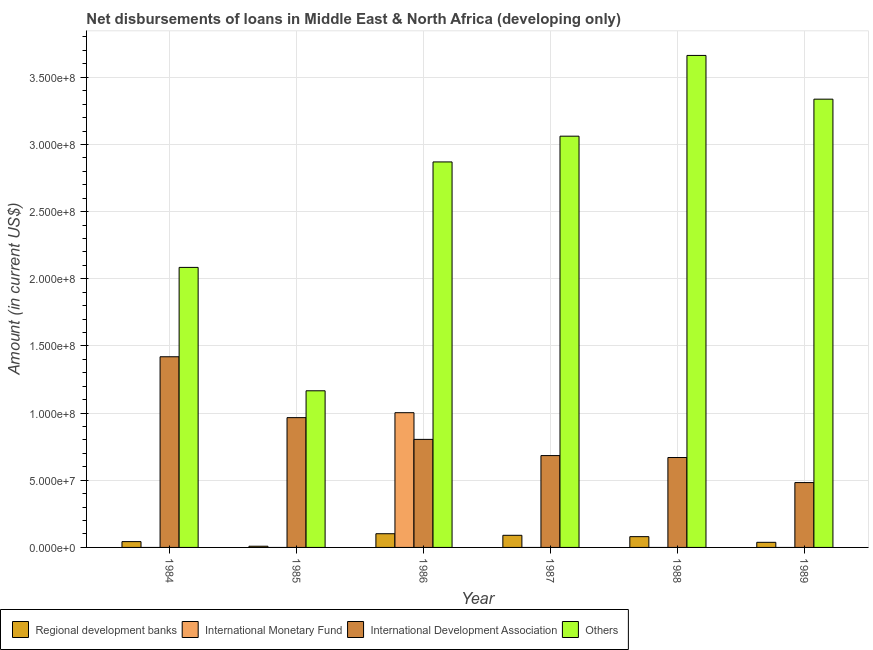How many different coloured bars are there?
Make the answer very short. 4. How many bars are there on the 3rd tick from the left?
Your response must be concise. 4. How many bars are there on the 5th tick from the right?
Provide a succinct answer. 3. What is the amount of loan disimbursed by other organisations in 1989?
Provide a succinct answer. 3.34e+08. Across all years, what is the maximum amount of loan disimbursed by international monetary fund?
Provide a short and direct response. 1.00e+08. Across all years, what is the minimum amount of loan disimbursed by other organisations?
Your answer should be very brief. 1.17e+08. In which year was the amount of loan disimbursed by international monetary fund maximum?
Offer a very short reply. 1986. What is the total amount of loan disimbursed by regional development banks in the graph?
Give a very brief answer. 3.63e+07. What is the difference between the amount of loan disimbursed by regional development banks in 1984 and that in 1987?
Offer a terse response. -4.69e+06. What is the difference between the amount of loan disimbursed by international development association in 1989 and the amount of loan disimbursed by international monetary fund in 1984?
Provide a short and direct response. -9.37e+07. What is the average amount of loan disimbursed by international monetary fund per year?
Provide a succinct answer. 1.67e+07. In the year 1987, what is the difference between the amount of loan disimbursed by other organisations and amount of loan disimbursed by international development association?
Offer a very short reply. 0. In how many years, is the amount of loan disimbursed by other organisations greater than 270000000 US$?
Your answer should be very brief. 4. What is the ratio of the amount of loan disimbursed by other organisations in 1985 to that in 1988?
Offer a terse response. 0.32. Is the difference between the amount of loan disimbursed by other organisations in 1987 and 1989 greater than the difference between the amount of loan disimbursed by international monetary fund in 1987 and 1989?
Ensure brevity in your answer.  No. What is the difference between the highest and the second highest amount of loan disimbursed by international development association?
Offer a terse response. 4.53e+07. What is the difference between the highest and the lowest amount of loan disimbursed by international monetary fund?
Provide a short and direct response. 1.00e+08. In how many years, is the amount of loan disimbursed by international development association greater than the average amount of loan disimbursed by international development association taken over all years?
Ensure brevity in your answer.  2. Is the sum of the amount of loan disimbursed by regional development banks in 1985 and 1988 greater than the maximum amount of loan disimbursed by international monetary fund across all years?
Your answer should be very brief. No. Is it the case that in every year, the sum of the amount of loan disimbursed by international development association and amount of loan disimbursed by regional development banks is greater than the sum of amount of loan disimbursed by international monetary fund and amount of loan disimbursed by other organisations?
Offer a very short reply. No. Is it the case that in every year, the sum of the amount of loan disimbursed by regional development banks and amount of loan disimbursed by international monetary fund is greater than the amount of loan disimbursed by international development association?
Provide a short and direct response. No. How many bars are there?
Your answer should be compact. 19. What is the title of the graph?
Provide a succinct answer. Net disbursements of loans in Middle East & North Africa (developing only). Does "Minerals" appear as one of the legend labels in the graph?
Offer a very short reply. No. What is the Amount (in current US$) of Regional development banks in 1984?
Provide a succinct answer. 4.33e+06. What is the Amount (in current US$) in International Development Association in 1984?
Your response must be concise. 1.42e+08. What is the Amount (in current US$) of Others in 1984?
Make the answer very short. 2.08e+08. What is the Amount (in current US$) in Regional development banks in 1985?
Your response must be concise. 8.91e+05. What is the Amount (in current US$) of International Monetary Fund in 1985?
Your answer should be compact. 0. What is the Amount (in current US$) in International Development Association in 1985?
Provide a succinct answer. 9.66e+07. What is the Amount (in current US$) in Others in 1985?
Keep it short and to the point. 1.17e+08. What is the Amount (in current US$) in Regional development banks in 1986?
Make the answer very short. 1.02e+07. What is the Amount (in current US$) of International Monetary Fund in 1986?
Make the answer very short. 1.00e+08. What is the Amount (in current US$) of International Development Association in 1986?
Offer a very short reply. 8.04e+07. What is the Amount (in current US$) in Others in 1986?
Keep it short and to the point. 2.87e+08. What is the Amount (in current US$) in Regional development banks in 1987?
Make the answer very short. 9.02e+06. What is the Amount (in current US$) of International Monetary Fund in 1987?
Keep it short and to the point. 0. What is the Amount (in current US$) of International Development Association in 1987?
Your answer should be very brief. 6.84e+07. What is the Amount (in current US$) of Others in 1987?
Ensure brevity in your answer.  3.06e+08. What is the Amount (in current US$) of Regional development banks in 1988?
Give a very brief answer. 8.03e+06. What is the Amount (in current US$) of International Development Association in 1988?
Provide a short and direct response. 6.69e+07. What is the Amount (in current US$) of Others in 1988?
Provide a succinct answer. 3.66e+08. What is the Amount (in current US$) of Regional development banks in 1989?
Keep it short and to the point. 3.80e+06. What is the Amount (in current US$) of International Development Association in 1989?
Your answer should be compact. 4.83e+07. What is the Amount (in current US$) in Others in 1989?
Make the answer very short. 3.34e+08. Across all years, what is the maximum Amount (in current US$) of Regional development banks?
Make the answer very short. 1.02e+07. Across all years, what is the maximum Amount (in current US$) in International Monetary Fund?
Provide a short and direct response. 1.00e+08. Across all years, what is the maximum Amount (in current US$) of International Development Association?
Give a very brief answer. 1.42e+08. Across all years, what is the maximum Amount (in current US$) in Others?
Make the answer very short. 3.66e+08. Across all years, what is the minimum Amount (in current US$) of Regional development banks?
Offer a very short reply. 8.91e+05. Across all years, what is the minimum Amount (in current US$) in International Development Association?
Your answer should be very brief. 4.83e+07. Across all years, what is the minimum Amount (in current US$) in Others?
Keep it short and to the point. 1.17e+08. What is the total Amount (in current US$) in Regional development banks in the graph?
Your answer should be very brief. 3.63e+07. What is the total Amount (in current US$) in International Monetary Fund in the graph?
Your response must be concise. 1.00e+08. What is the total Amount (in current US$) in International Development Association in the graph?
Give a very brief answer. 5.03e+08. What is the total Amount (in current US$) of Others in the graph?
Give a very brief answer. 1.62e+09. What is the difference between the Amount (in current US$) of Regional development banks in 1984 and that in 1985?
Keep it short and to the point. 3.44e+06. What is the difference between the Amount (in current US$) in International Development Association in 1984 and that in 1985?
Keep it short and to the point. 4.53e+07. What is the difference between the Amount (in current US$) of Others in 1984 and that in 1985?
Offer a very short reply. 9.19e+07. What is the difference between the Amount (in current US$) in Regional development banks in 1984 and that in 1986?
Ensure brevity in your answer.  -5.86e+06. What is the difference between the Amount (in current US$) of International Development Association in 1984 and that in 1986?
Give a very brief answer. 6.15e+07. What is the difference between the Amount (in current US$) in Others in 1984 and that in 1986?
Provide a short and direct response. -7.85e+07. What is the difference between the Amount (in current US$) of Regional development banks in 1984 and that in 1987?
Give a very brief answer. -4.69e+06. What is the difference between the Amount (in current US$) in International Development Association in 1984 and that in 1987?
Ensure brevity in your answer.  7.36e+07. What is the difference between the Amount (in current US$) in Others in 1984 and that in 1987?
Ensure brevity in your answer.  -9.77e+07. What is the difference between the Amount (in current US$) in Regional development banks in 1984 and that in 1988?
Your answer should be very brief. -3.70e+06. What is the difference between the Amount (in current US$) in International Development Association in 1984 and that in 1988?
Ensure brevity in your answer.  7.50e+07. What is the difference between the Amount (in current US$) in Others in 1984 and that in 1988?
Your answer should be compact. -1.58e+08. What is the difference between the Amount (in current US$) in Regional development banks in 1984 and that in 1989?
Make the answer very short. 5.32e+05. What is the difference between the Amount (in current US$) of International Development Association in 1984 and that in 1989?
Offer a very short reply. 9.37e+07. What is the difference between the Amount (in current US$) in Others in 1984 and that in 1989?
Keep it short and to the point. -1.25e+08. What is the difference between the Amount (in current US$) in Regional development banks in 1985 and that in 1986?
Offer a very short reply. -9.30e+06. What is the difference between the Amount (in current US$) of International Development Association in 1985 and that in 1986?
Your response must be concise. 1.62e+07. What is the difference between the Amount (in current US$) of Others in 1985 and that in 1986?
Keep it short and to the point. -1.70e+08. What is the difference between the Amount (in current US$) in Regional development banks in 1985 and that in 1987?
Your response must be concise. -8.13e+06. What is the difference between the Amount (in current US$) of International Development Association in 1985 and that in 1987?
Offer a very short reply. 2.83e+07. What is the difference between the Amount (in current US$) in Others in 1985 and that in 1987?
Your response must be concise. -1.90e+08. What is the difference between the Amount (in current US$) in Regional development banks in 1985 and that in 1988?
Keep it short and to the point. -7.14e+06. What is the difference between the Amount (in current US$) of International Development Association in 1985 and that in 1988?
Offer a very short reply. 2.97e+07. What is the difference between the Amount (in current US$) in Others in 1985 and that in 1988?
Your response must be concise. -2.50e+08. What is the difference between the Amount (in current US$) of Regional development banks in 1985 and that in 1989?
Your answer should be compact. -2.91e+06. What is the difference between the Amount (in current US$) in International Development Association in 1985 and that in 1989?
Give a very brief answer. 4.84e+07. What is the difference between the Amount (in current US$) of Others in 1985 and that in 1989?
Your answer should be compact. -2.17e+08. What is the difference between the Amount (in current US$) in Regional development banks in 1986 and that in 1987?
Make the answer very short. 1.17e+06. What is the difference between the Amount (in current US$) of International Development Association in 1986 and that in 1987?
Make the answer very short. 1.21e+07. What is the difference between the Amount (in current US$) in Others in 1986 and that in 1987?
Keep it short and to the point. -1.92e+07. What is the difference between the Amount (in current US$) of Regional development banks in 1986 and that in 1988?
Provide a succinct answer. 2.16e+06. What is the difference between the Amount (in current US$) of International Development Association in 1986 and that in 1988?
Provide a succinct answer. 1.35e+07. What is the difference between the Amount (in current US$) of Others in 1986 and that in 1988?
Your answer should be compact. -7.93e+07. What is the difference between the Amount (in current US$) of Regional development banks in 1986 and that in 1989?
Offer a terse response. 6.40e+06. What is the difference between the Amount (in current US$) of International Development Association in 1986 and that in 1989?
Provide a succinct answer. 3.22e+07. What is the difference between the Amount (in current US$) in Others in 1986 and that in 1989?
Your response must be concise. -4.67e+07. What is the difference between the Amount (in current US$) in Regional development banks in 1987 and that in 1988?
Ensure brevity in your answer.  9.90e+05. What is the difference between the Amount (in current US$) in International Development Association in 1987 and that in 1988?
Keep it short and to the point. 1.45e+06. What is the difference between the Amount (in current US$) of Others in 1987 and that in 1988?
Your response must be concise. -6.01e+07. What is the difference between the Amount (in current US$) of Regional development banks in 1987 and that in 1989?
Your answer should be compact. 5.22e+06. What is the difference between the Amount (in current US$) of International Development Association in 1987 and that in 1989?
Your answer should be compact. 2.01e+07. What is the difference between the Amount (in current US$) of Others in 1987 and that in 1989?
Provide a short and direct response. -2.76e+07. What is the difference between the Amount (in current US$) in Regional development banks in 1988 and that in 1989?
Your answer should be compact. 4.23e+06. What is the difference between the Amount (in current US$) of International Development Association in 1988 and that in 1989?
Your answer should be compact. 1.87e+07. What is the difference between the Amount (in current US$) of Others in 1988 and that in 1989?
Keep it short and to the point. 3.26e+07. What is the difference between the Amount (in current US$) of Regional development banks in 1984 and the Amount (in current US$) of International Development Association in 1985?
Make the answer very short. -9.23e+07. What is the difference between the Amount (in current US$) in Regional development banks in 1984 and the Amount (in current US$) in Others in 1985?
Ensure brevity in your answer.  -1.12e+08. What is the difference between the Amount (in current US$) in International Development Association in 1984 and the Amount (in current US$) in Others in 1985?
Offer a very short reply. 2.53e+07. What is the difference between the Amount (in current US$) in Regional development banks in 1984 and the Amount (in current US$) in International Monetary Fund in 1986?
Offer a very short reply. -9.60e+07. What is the difference between the Amount (in current US$) in Regional development banks in 1984 and the Amount (in current US$) in International Development Association in 1986?
Keep it short and to the point. -7.61e+07. What is the difference between the Amount (in current US$) of Regional development banks in 1984 and the Amount (in current US$) of Others in 1986?
Offer a terse response. -2.83e+08. What is the difference between the Amount (in current US$) in International Development Association in 1984 and the Amount (in current US$) in Others in 1986?
Provide a succinct answer. -1.45e+08. What is the difference between the Amount (in current US$) in Regional development banks in 1984 and the Amount (in current US$) in International Development Association in 1987?
Your answer should be compact. -6.40e+07. What is the difference between the Amount (in current US$) of Regional development banks in 1984 and the Amount (in current US$) of Others in 1987?
Keep it short and to the point. -3.02e+08. What is the difference between the Amount (in current US$) of International Development Association in 1984 and the Amount (in current US$) of Others in 1987?
Offer a terse response. -1.64e+08. What is the difference between the Amount (in current US$) of Regional development banks in 1984 and the Amount (in current US$) of International Development Association in 1988?
Provide a short and direct response. -6.26e+07. What is the difference between the Amount (in current US$) of Regional development banks in 1984 and the Amount (in current US$) of Others in 1988?
Offer a very short reply. -3.62e+08. What is the difference between the Amount (in current US$) of International Development Association in 1984 and the Amount (in current US$) of Others in 1988?
Provide a short and direct response. -2.24e+08. What is the difference between the Amount (in current US$) of Regional development banks in 1984 and the Amount (in current US$) of International Development Association in 1989?
Your response must be concise. -4.39e+07. What is the difference between the Amount (in current US$) of Regional development banks in 1984 and the Amount (in current US$) of Others in 1989?
Offer a terse response. -3.29e+08. What is the difference between the Amount (in current US$) of International Development Association in 1984 and the Amount (in current US$) of Others in 1989?
Offer a terse response. -1.92e+08. What is the difference between the Amount (in current US$) of Regional development banks in 1985 and the Amount (in current US$) of International Monetary Fund in 1986?
Ensure brevity in your answer.  -9.94e+07. What is the difference between the Amount (in current US$) in Regional development banks in 1985 and the Amount (in current US$) in International Development Association in 1986?
Provide a succinct answer. -7.95e+07. What is the difference between the Amount (in current US$) in Regional development banks in 1985 and the Amount (in current US$) in Others in 1986?
Offer a terse response. -2.86e+08. What is the difference between the Amount (in current US$) of International Development Association in 1985 and the Amount (in current US$) of Others in 1986?
Make the answer very short. -1.90e+08. What is the difference between the Amount (in current US$) of Regional development banks in 1985 and the Amount (in current US$) of International Development Association in 1987?
Your answer should be compact. -6.75e+07. What is the difference between the Amount (in current US$) in Regional development banks in 1985 and the Amount (in current US$) in Others in 1987?
Keep it short and to the point. -3.05e+08. What is the difference between the Amount (in current US$) in International Development Association in 1985 and the Amount (in current US$) in Others in 1987?
Your answer should be compact. -2.10e+08. What is the difference between the Amount (in current US$) of Regional development banks in 1985 and the Amount (in current US$) of International Development Association in 1988?
Your answer should be very brief. -6.60e+07. What is the difference between the Amount (in current US$) of Regional development banks in 1985 and the Amount (in current US$) of Others in 1988?
Ensure brevity in your answer.  -3.65e+08. What is the difference between the Amount (in current US$) of International Development Association in 1985 and the Amount (in current US$) of Others in 1988?
Give a very brief answer. -2.70e+08. What is the difference between the Amount (in current US$) of Regional development banks in 1985 and the Amount (in current US$) of International Development Association in 1989?
Keep it short and to the point. -4.74e+07. What is the difference between the Amount (in current US$) in Regional development banks in 1985 and the Amount (in current US$) in Others in 1989?
Your answer should be very brief. -3.33e+08. What is the difference between the Amount (in current US$) of International Development Association in 1985 and the Amount (in current US$) of Others in 1989?
Give a very brief answer. -2.37e+08. What is the difference between the Amount (in current US$) in Regional development banks in 1986 and the Amount (in current US$) in International Development Association in 1987?
Make the answer very short. -5.82e+07. What is the difference between the Amount (in current US$) of Regional development banks in 1986 and the Amount (in current US$) of Others in 1987?
Give a very brief answer. -2.96e+08. What is the difference between the Amount (in current US$) in International Monetary Fund in 1986 and the Amount (in current US$) in International Development Association in 1987?
Offer a very short reply. 3.19e+07. What is the difference between the Amount (in current US$) of International Monetary Fund in 1986 and the Amount (in current US$) of Others in 1987?
Your answer should be very brief. -2.06e+08. What is the difference between the Amount (in current US$) of International Development Association in 1986 and the Amount (in current US$) of Others in 1987?
Offer a terse response. -2.26e+08. What is the difference between the Amount (in current US$) in Regional development banks in 1986 and the Amount (in current US$) in International Development Association in 1988?
Give a very brief answer. -5.67e+07. What is the difference between the Amount (in current US$) of Regional development banks in 1986 and the Amount (in current US$) of Others in 1988?
Offer a terse response. -3.56e+08. What is the difference between the Amount (in current US$) of International Monetary Fund in 1986 and the Amount (in current US$) of International Development Association in 1988?
Your response must be concise. 3.34e+07. What is the difference between the Amount (in current US$) of International Monetary Fund in 1986 and the Amount (in current US$) of Others in 1988?
Offer a terse response. -2.66e+08. What is the difference between the Amount (in current US$) in International Development Association in 1986 and the Amount (in current US$) in Others in 1988?
Your answer should be very brief. -2.86e+08. What is the difference between the Amount (in current US$) in Regional development banks in 1986 and the Amount (in current US$) in International Development Association in 1989?
Your answer should be very brief. -3.81e+07. What is the difference between the Amount (in current US$) in Regional development banks in 1986 and the Amount (in current US$) in Others in 1989?
Provide a short and direct response. -3.24e+08. What is the difference between the Amount (in current US$) of International Monetary Fund in 1986 and the Amount (in current US$) of International Development Association in 1989?
Offer a terse response. 5.20e+07. What is the difference between the Amount (in current US$) of International Monetary Fund in 1986 and the Amount (in current US$) of Others in 1989?
Provide a short and direct response. -2.33e+08. What is the difference between the Amount (in current US$) in International Development Association in 1986 and the Amount (in current US$) in Others in 1989?
Your answer should be compact. -2.53e+08. What is the difference between the Amount (in current US$) in Regional development banks in 1987 and the Amount (in current US$) in International Development Association in 1988?
Your answer should be compact. -5.79e+07. What is the difference between the Amount (in current US$) in Regional development banks in 1987 and the Amount (in current US$) in Others in 1988?
Offer a terse response. -3.57e+08. What is the difference between the Amount (in current US$) in International Development Association in 1987 and the Amount (in current US$) in Others in 1988?
Your answer should be compact. -2.98e+08. What is the difference between the Amount (in current US$) of Regional development banks in 1987 and the Amount (in current US$) of International Development Association in 1989?
Your response must be concise. -3.92e+07. What is the difference between the Amount (in current US$) of Regional development banks in 1987 and the Amount (in current US$) of Others in 1989?
Give a very brief answer. -3.25e+08. What is the difference between the Amount (in current US$) of International Development Association in 1987 and the Amount (in current US$) of Others in 1989?
Your answer should be compact. -2.65e+08. What is the difference between the Amount (in current US$) in Regional development banks in 1988 and the Amount (in current US$) in International Development Association in 1989?
Your answer should be very brief. -4.02e+07. What is the difference between the Amount (in current US$) of Regional development banks in 1988 and the Amount (in current US$) of Others in 1989?
Offer a very short reply. -3.26e+08. What is the difference between the Amount (in current US$) of International Development Association in 1988 and the Amount (in current US$) of Others in 1989?
Keep it short and to the point. -2.67e+08. What is the average Amount (in current US$) of Regional development banks per year?
Provide a short and direct response. 6.04e+06. What is the average Amount (in current US$) in International Monetary Fund per year?
Keep it short and to the point. 1.67e+07. What is the average Amount (in current US$) in International Development Association per year?
Make the answer very short. 8.38e+07. What is the average Amount (in current US$) in Others per year?
Offer a terse response. 2.70e+08. In the year 1984, what is the difference between the Amount (in current US$) of Regional development banks and Amount (in current US$) of International Development Association?
Your answer should be very brief. -1.38e+08. In the year 1984, what is the difference between the Amount (in current US$) in Regional development banks and Amount (in current US$) in Others?
Give a very brief answer. -2.04e+08. In the year 1984, what is the difference between the Amount (in current US$) of International Development Association and Amount (in current US$) of Others?
Your answer should be very brief. -6.65e+07. In the year 1985, what is the difference between the Amount (in current US$) of Regional development banks and Amount (in current US$) of International Development Association?
Keep it short and to the point. -9.57e+07. In the year 1985, what is the difference between the Amount (in current US$) of Regional development banks and Amount (in current US$) of Others?
Your answer should be compact. -1.16e+08. In the year 1985, what is the difference between the Amount (in current US$) of International Development Association and Amount (in current US$) of Others?
Your answer should be very brief. -2.00e+07. In the year 1986, what is the difference between the Amount (in current US$) in Regional development banks and Amount (in current US$) in International Monetary Fund?
Offer a very short reply. -9.01e+07. In the year 1986, what is the difference between the Amount (in current US$) in Regional development banks and Amount (in current US$) in International Development Association?
Provide a short and direct response. -7.02e+07. In the year 1986, what is the difference between the Amount (in current US$) of Regional development banks and Amount (in current US$) of Others?
Give a very brief answer. -2.77e+08. In the year 1986, what is the difference between the Amount (in current US$) in International Monetary Fund and Amount (in current US$) in International Development Association?
Provide a succinct answer. 1.99e+07. In the year 1986, what is the difference between the Amount (in current US$) of International Monetary Fund and Amount (in current US$) of Others?
Give a very brief answer. -1.87e+08. In the year 1986, what is the difference between the Amount (in current US$) of International Development Association and Amount (in current US$) of Others?
Your response must be concise. -2.07e+08. In the year 1987, what is the difference between the Amount (in current US$) of Regional development banks and Amount (in current US$) of International Development Association?
Provide a short and direct response. -5.94e+07. In the year 1987, what is the difference between the Amount (in current US$) of Regional development banks and Amount (in current US$) of Others?
Offer a very short reply. -2.97e+08. In the year 1987, what is the difference between the Amount (in current US$) in International Development Association and Amount (in current US$) in Others?
Ensure brevity in your answer.  -2.38e+08. In the year 1988, what is the difference between the Amount (in current US$) of Regional development banks and Amount (in current US$) of International Development Association?
Give a very brief answer. -5.89e+07. In the year 1988, what is the difference between the Amount (in current US$) in Regional development banks and Amount (in current US$) in Others?
Your answer should be very brief. -3.58e+08. In the year 1988, what is the difference between the Amount (in current US$) in International Development Association and Amount (in current US$) in Others?
Offer a very short reply. -2.99e+08. In the year 1989, what is the difference between the Amount (in current US$) in Regional development banks and Amount (in current US$) in International Development Association?
Provide a succinct answer. -4.45e+07. In the year 1989, what is the difference between the Amount (in current US$) in Regional development banks and Amount (in current US$) in Others?
Provide a short and direct response. -3.30e+08. In the year 1989, what is the difference between the Amount (in current US$) in International Development Association and Amount (in current US$) in Others?
Your answer should be compact. -2.85e+08. What is the ratio of the Amount (in current US$) of Regional development banks in 1984 to that in 1985?
Your answer should be very brief. 4.86. What is the ratio of the Amount (in current US$) of International Development Association in 1984 to that in 1985?
Provide a succinct answer. 1.47. What is the ratio of the Amount (in current US$) in Others in 1984 to that in 1985?
Keep it short and to the point. 1.79. What is the ratio of the Amount (in current US$) in Regional development banks in 1984 to that in 1986?
Make the answer very short. 0.42. What is the ratio of the Amount (in current US$) in International Development Association in 1984 to that in 1986?
Make the answer very short. 1.76. What is the ratio of the Amount (in current US$) in Others in 1984 to that in 1986?
Keep it short and to the point. 0.73. What is the ratio of the Amount (in current US$) in Regional development banks in 1984 to that in 1987?
Provide a short and direct response. 0.48. What is the ratio of the Amount (in current US$) of International Development Association in 1984 to that in 1987?
Your response must be concise. 2.08. What is the ratio of the Amount (in current US$) in Others in 1984 to that in 1987?
Keep it short and to the point. 0.68. What is the ratio of the Amount (in current US$) of Regional development banks in 1984 to that in 1988?
Make the answer very short. 0.54. What is the ratio of the Amount (in current US$) in International Development Association in 1984 to that in 1988?
Your response must be concise. 2.12. What is the ratio of the Amount (in current US$) in Others in 1984 to that in 1988?
Ensure brevity in your answer.  0.57. What is the ratio of the Amount (in current US$) of Regional development banks in 1984 to that in 1989?
Make the answer very short. 1.14. What is the ratio of the Amount (in current US$) in International Development Association in 1984 to that in 1989?
Offer a terse response. 2.94. What is the ratio of the Amount (in current US$) in Others in 1984 to that in 1989?
Offer a very short reply. 0.62. What is the ratio of the Amount (in current US$) of Regional development banks in 1985 to that in 1986?
Give a very brief answer. 0.09. What is the ratio of the Amount (in current US$) of International Development Association in 1985 to that in 1986?
Your answer should be very brief. 1.2. What is the ratio of the Amount (in current US$) of Others in 1985 to that in 1986?
Your answer should be compact. 0.41. What is the ratio of the Amount (in current US$) in Regional development banks in 1985 to that in 1987?
Keep it short and to the point. 0.1. What is the ratio of the Amount (in current US$) in International Development Association in 1985 to that in 1987?
Provide a short and direct response. 1.41. What is the ratio of the Amount (in current US$) in Others in 1985 to that in 1987?
Offer a very short reply. 0.38. What is the ratio of the Amount (in current US$) in Regional development banks in 1985 to that in 1988?
Offer a very short reply. 0.11. What is the ratio of the Amount (in current US$) in International Development Association in 1985 to that in 1988?
Your answer should be very brief. 1.44. What is the ratio of the Amount (in current US$) of Others in 1985 to that in 1988?
Your response must be concise. 0.32. What is the ratio of the Amount (in current US$) of Regional development banks in 1985 to that in 1989?
Your response must be concise. 0.23. What is the ratio of the Amount (in current US$) in International Development Association in 1985 to that in 1989?
Provide a succinct answer. 2. What is the ratio of the Amount (in current US$) of Others in 1985 to that in 1989?
Ensure brevity in your answer.  0.35. What is the ratio of the Amount (in current US$) of Regional development banks in 1986 to that in 1987?
Offer a terse response. 1.13. What is the ratio of the Amount (in current US$) of International Development Association in 1986 to that in 1987?
Make the answer very short. 1.18. What is the ratio of the Amount (in current US$) in Others in 1986 to that in 1987?
Provide a succinct answer. 0.94. What is the ratio of the Amount (in current US$) of Regional development banks in 1986 to that in 1988?
Provide a succinct answer. 1.27. What is the ratio of the Amount (in current US$) in International Development Association in 1986 to that in 1988?
Offer a very short reply. 1.2. What is the ratio of the Amount (in current US$) of Others in 1986 to that in 1988?
Make the answer very short. 0.78. What is the ratio of the Amount (in current US$) in Regional development banks in 1986 to that in 1989?
Offer a terse response. 2.68. What is the ratio of the Amount (in current US$) in International Development Association in 1986 to that in 1989?
Make the answer very short. 1.67. What is the ratio of the Amount (in current US$) of Others in 1986 to that in 1989?
Your answer should be compact. 0.86. What is the ratio of the Amount (in current US$) in Regional development banks in 1987 to that in 1988?
Make the answer very short. 1.12. What is the ratio of the Amount (in current US$) in International Development Association in 1987 to that in 1988?
Make the answer very short. 1.02. What is the ratio of the Amount (in current US$) of Others in 1987 to that in 1988?
Provide a short and direct response. 0.84. What is the ratio of the Amount (in current US$) of Regional development banks in 1987 to that in 1989?
Keep it short and to the point. 2.38. What is the ratio of the Amount (in current US$) of International Development Association in 1987 to that in 1989?
Offer a terse response. 1.42. What is the ratio of the Amount (in current US$) in Others in 1987 to that in 1989?
Make the answer very short. 0.92. What is the ratio of the Amount (in current US$) of Regional development banks in 1988 to that in 1989?
Ensure brevity in your answer.  2.11. What is the ratio of the Amount (in current US$) of International Development Association in 1988 to that in 1989?
Your answer should be very brief. 1.39. What is the ratio of the Amount (in current US$) in Others in 1988 to that in 1989?
Your answer should be very brief. 1.1. What is the difference between the highest and the second highest Amount (in current US$) in Regional development banks?
Ensure brevity in your answer.  1.17e+06. What is the difference between the highest and the second highest Amount (in current US$) in International Development Association?
Your response must be concise. 4.53e+07. What is the difference between the highest and the second highest Amount (in current US$) in Others?
Make the answer very short. 3.26e+07. What is the difference between the highest and the lowest Amount (in current US$) in Regional development banks?
Give a very brief answer. 9.30e+06. What is the difference between the highest and the lowest Amount (in current US$) in International Monetary Fund?
Keep it short and to the point. 1.00e+08. What is the difference between the highest and the lowest Amount (in current US$) of International Development Association?
Keep it short and to the point. 9.37e+07. What is the difference between the highest and the lowest Amount (in current US$) of Others?
Provide a succinct answer. 2.50e+08. 